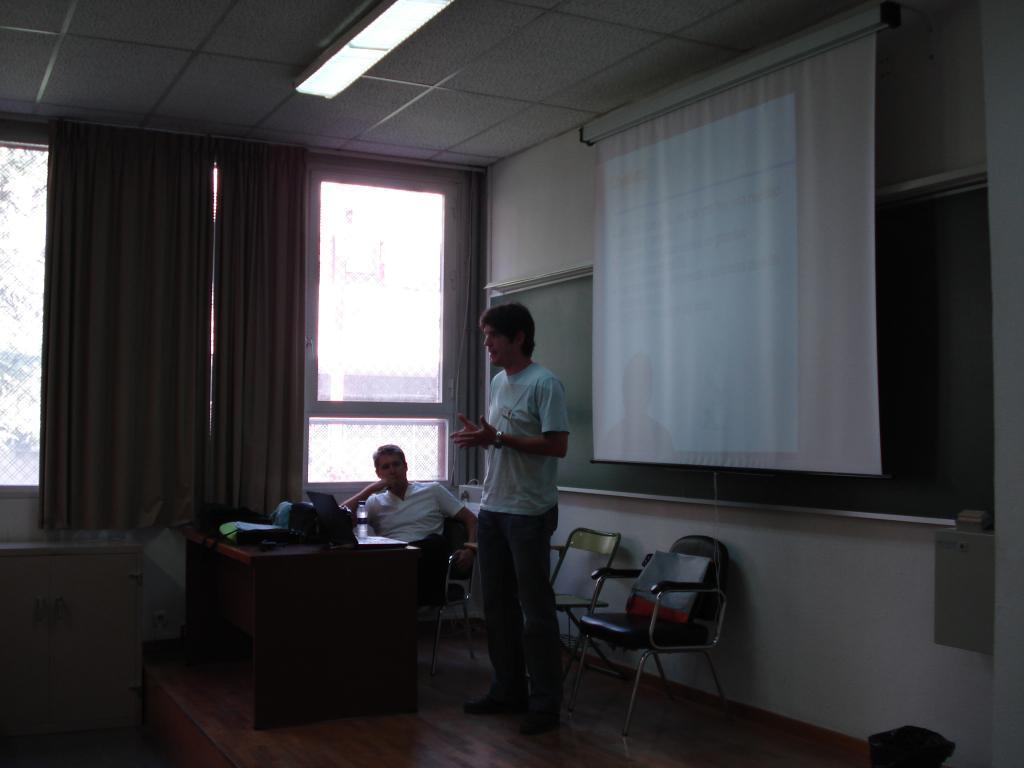Could you give a brief overview of what you see in this image? In this image, we can see a person wearing clothes and standing in front of the screen. There are chairs at the bottom of the image. There is an another person sitting on the chair in front of the table beside the window. There are curtains on the left side of the image. There is a light on the ceiling which is at the top of the image. There is a board on the right side of the image. 